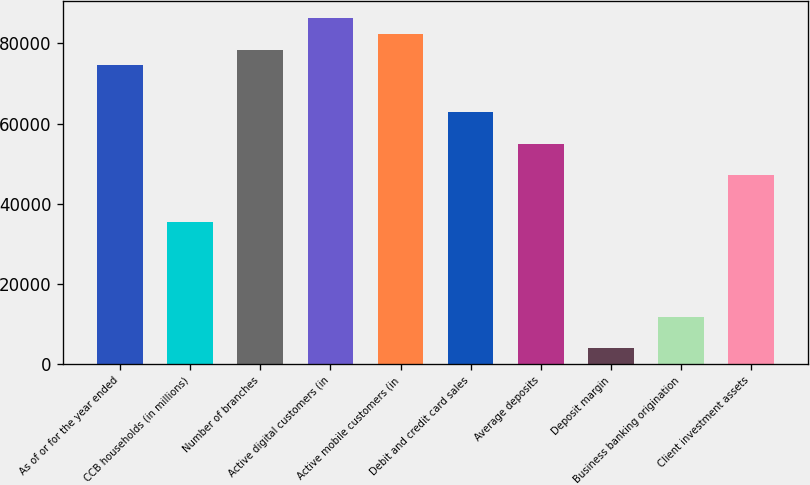Convert chart to OTSL. <chart><loc_0><loc_0><loc_500><loc_500><bar_chart><fcel>As of or for the year ended<fcel>CCB households (in millions)<fcel>Number of branches<fcel>Active digital customers (in<fcel>Active mobile customers (in<fcel>Debit and credit card sales<fcel>Average deposits<fcel>Deposit margin<fcel>Business banking origination<fcel>Client investment assets<nl><fcel>74558.9<fcel>35317.9<fcel>78483<fcel>86331.2<fcel>82407.1<fcel>62786.6<fcel>54938.4<fcel>3925.08<fcel>11773.3<fcel>47090.2<nl></chart> 